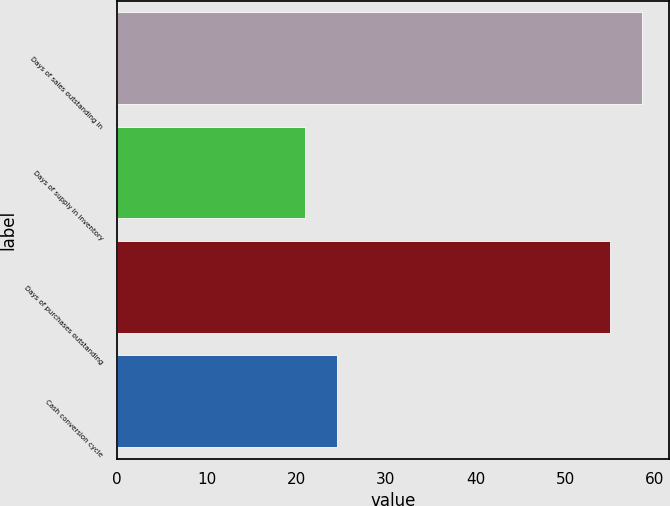Convert chart to OTSL. <chart><loc_0><loc_0><loc_500><loc_500><bar_chart><fcel>Days of sales outstanding in<fcel>Days of supply in inventory<fcel>Days of purchases outstanding<fcel>Cash conversion cycle<nl><fcel>58.6<fcel>21<fcel>55<fcel>24.6<nl></chart> 